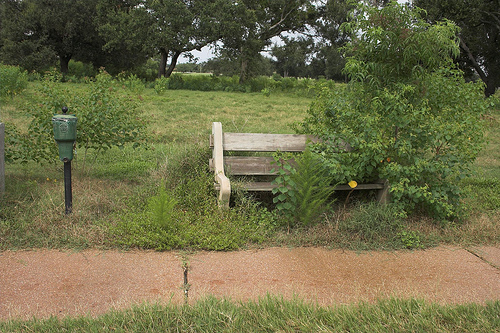<image>
Is there a can in the bush? No. The can is not contained within the bush. These objects have a different spatial relationship. 